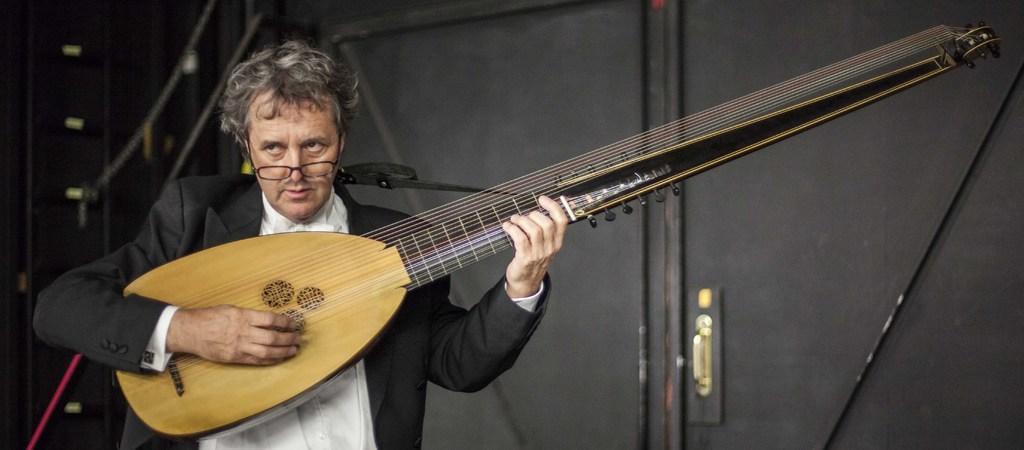Could you give a brief overview of what you see in this image? It looks like a concert, a man who is wearing a black color shirt is holding a big guitar in his hand, it has a lot of strings in the background there is a black color door, to the left side there are speakers. 